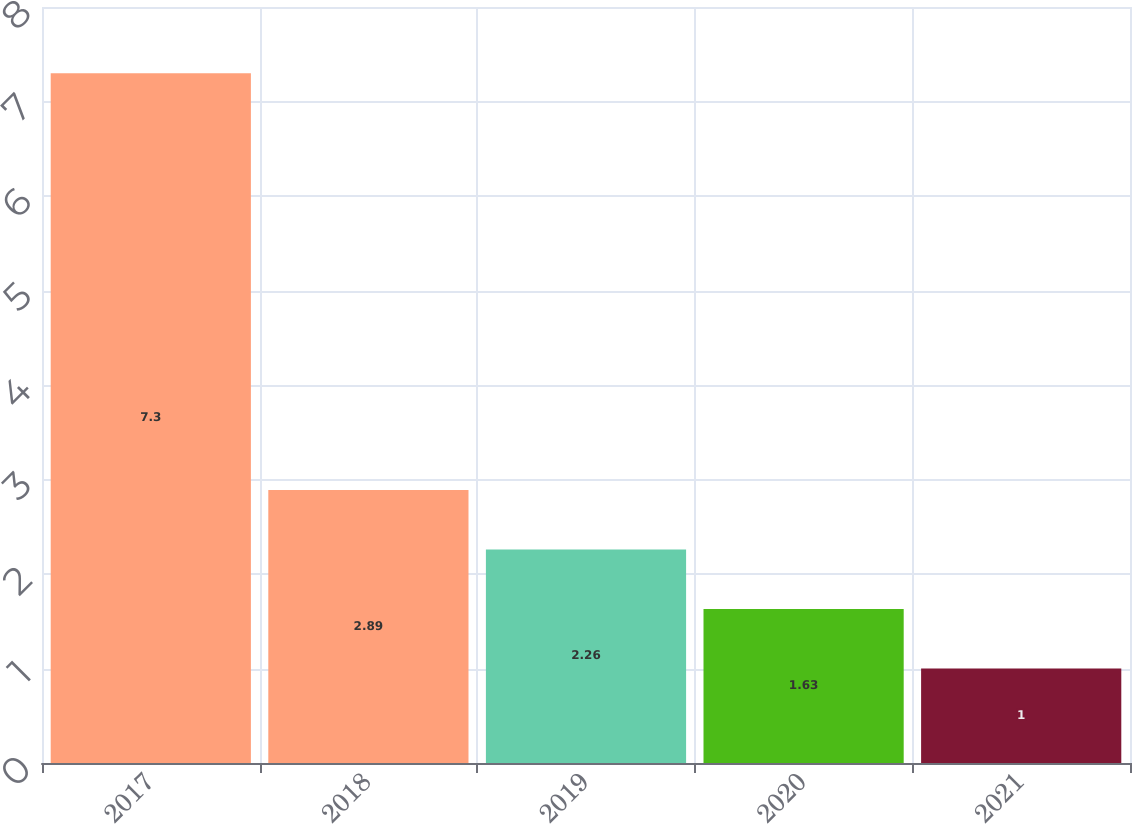Convert chart to OTSL. <chart><loc_0><loc_0><loc_500><loc_500><bar_chart><fcel>2017<fcel>2018<fcel>2019<fcel>2020<fcel>2021<nl><fcel>7.3<fcel>2.89<fcel>2.26<fcel>1.63<fcel>1<nl></chart> 